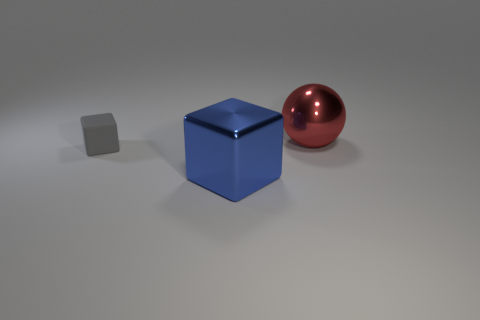Add 3 tiny gray rubber objects. How many objects exist? 6 Subtract all cubes. How many objects are left? 1 Add 3 gray blocks. How many gray blocks exist? 4 Subtract 0 cyan cylinders. How many objects are left? 3 Subtract all big metallic balls. Subtract all red shiny blocks. How many objects are left? 2 Add 1 gray matte cubes. How many gray matte cubes are left? 2 